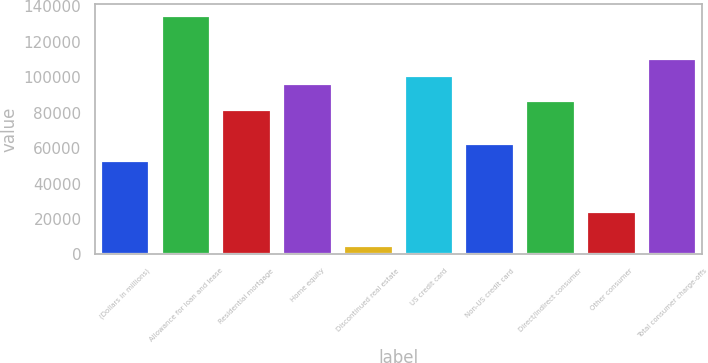Convert chart to OTSL. <chart><loc_0><loc_0><loc_500><loc_500><bar_chart><fcel>(Dollars in millions)<fcel>Allowance for loan and lease<fcel>Residential mortgage<fcel>Home equity<fcel>Discontinued real estate<fcel>US credit card<fcel>Non-US credit card<fcel>Direct/Indirect consumer<fcel>Other consumer<fcel>Total consumer charge-offs<nl><fcel>52783.2<fcel>134302<fcel>81554.4<fcel>95940<fcel>4831.2<fcel>100735<fcel>62373.6<fcel>86349.6<fcel>24012<fcel>110326<nl></chart> 